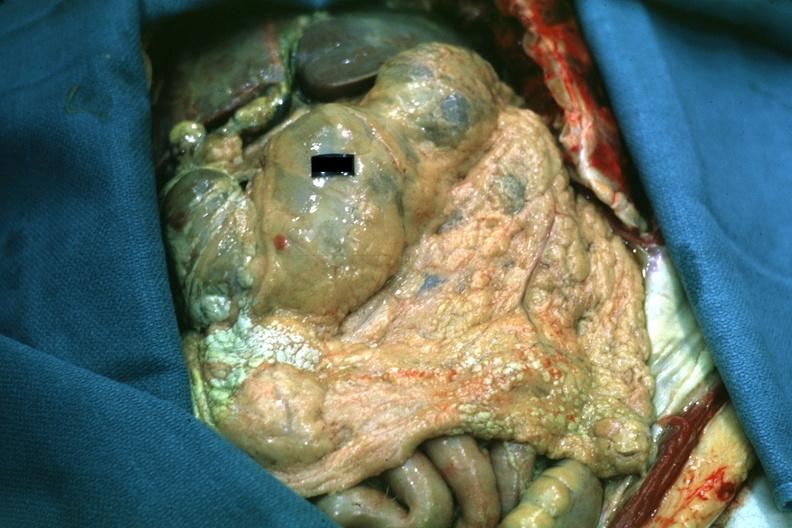does this image show opened abdomen with obvious large area of fat necrosis case of perforated ulcer with peritonitis which can not be seen in this photo why all the fat necrosis is not clear?
Answer the question using a single word or phrase. Yes 